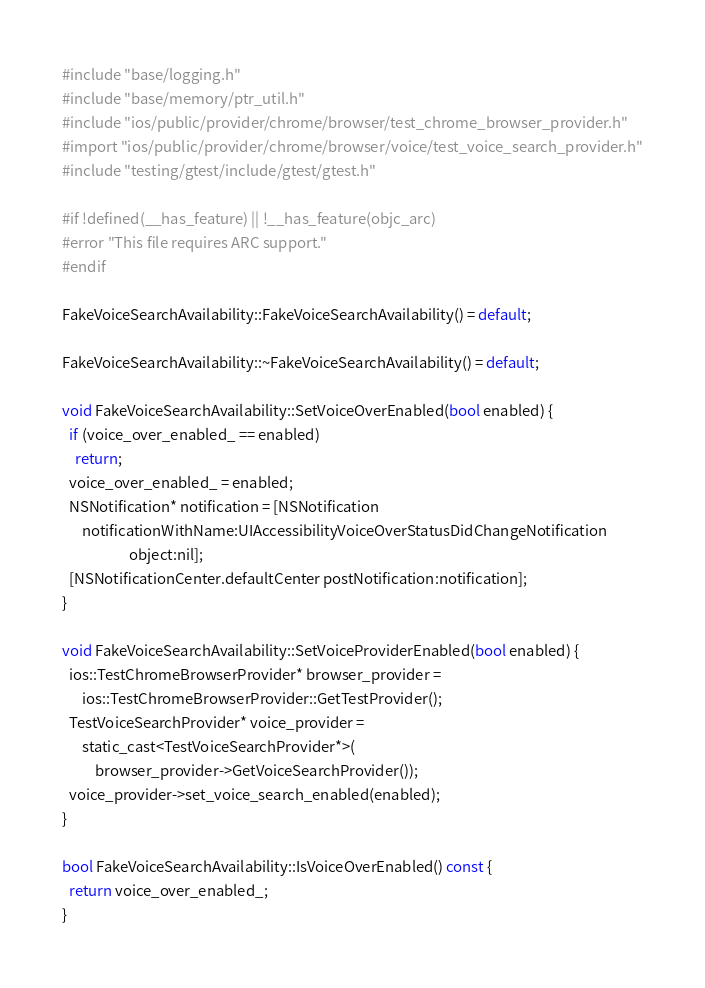Convert code to text. <code><loc_0><loc_0><loc_500><loc_500><_ObjectiveC_>#include "base/logging.h"
#include "base/memory/ptr_util.h"
#include "ios/public/provider/chrome/browser/test_chrome_browser_provider.h"
#import "ios/public/provider/chrome/browser/voice/test_voice_search_provider.h"
#include "testing/gtest/include/gtest/gtest.h"

#if !defined(__has_feature) || !__has_feature(objc_arc)
#error "This file requires ARC support."
#endif

FakeVoiceSearchAvailability::FakeVoiceSearchAvailability() = default;

FakeVoiceSearchAvailability::~FakeVoiceSearchAvailability() = default;

void FakeVoiceSearchAvailability::SetVoiceOverEnabled(bool enabled) {
  if (voice_over_enabled_ == enabled)
    return;
  voice_over_enabled_ = enabled;
  NSNotification* notification = [NSNotification
      notificationWithName:UIAccessibilityVoiceOverStatusDidChangeNotification
                    object:nil];
  [NSNotificationCenter.defaultCenter postNotification:notification];
}

void FakeVoiceSearchAvailability::SetVoiceProviderEnabled(bool enabled) {
  ios::TestChromeBrowserProvider* browser_provider =
      ios::TestChromeBrowserProvider::GetTestProvider();
  TestVoiceSearchProvider* voice_provider =
      static_cast<TestVoiceSearchProvider*>(
          browser_provider->GetVoiceSearchProvider());
  voice_provider->set_voice_search_enabled(enabled);
}

bool FakeVoiceSearchAvailability::IsVoiceOverEnabled() const {
  return voice_over_enabled_;
}
</code> 